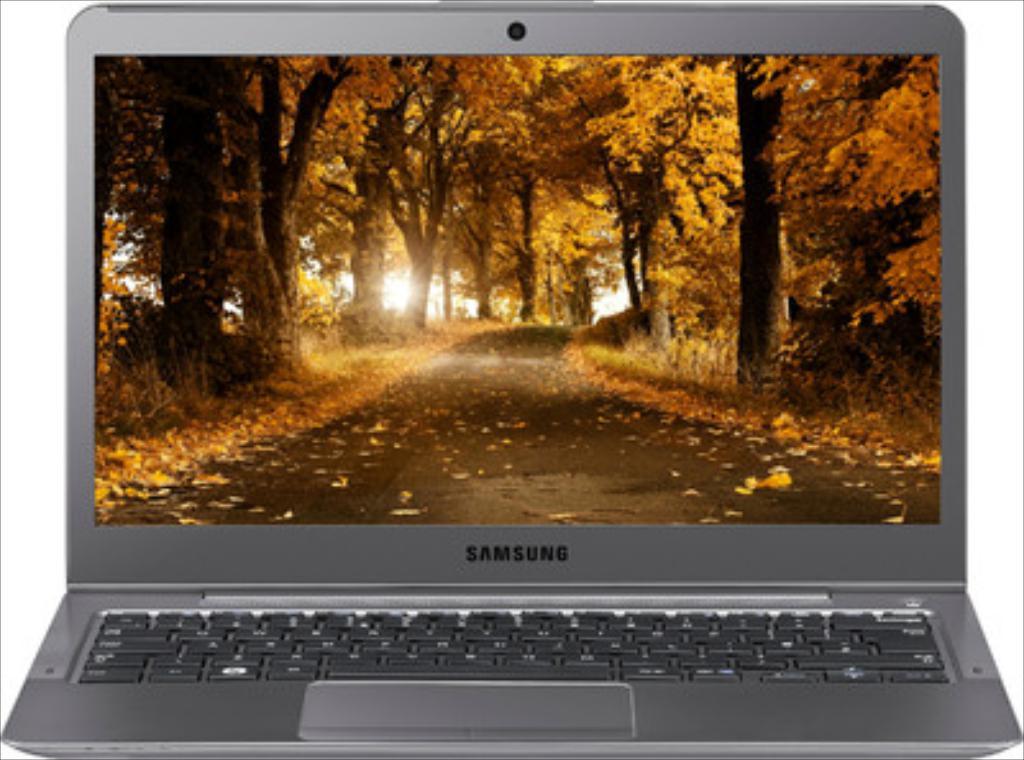What brand is the laptop?
Your answer should be compact. Samsung. 